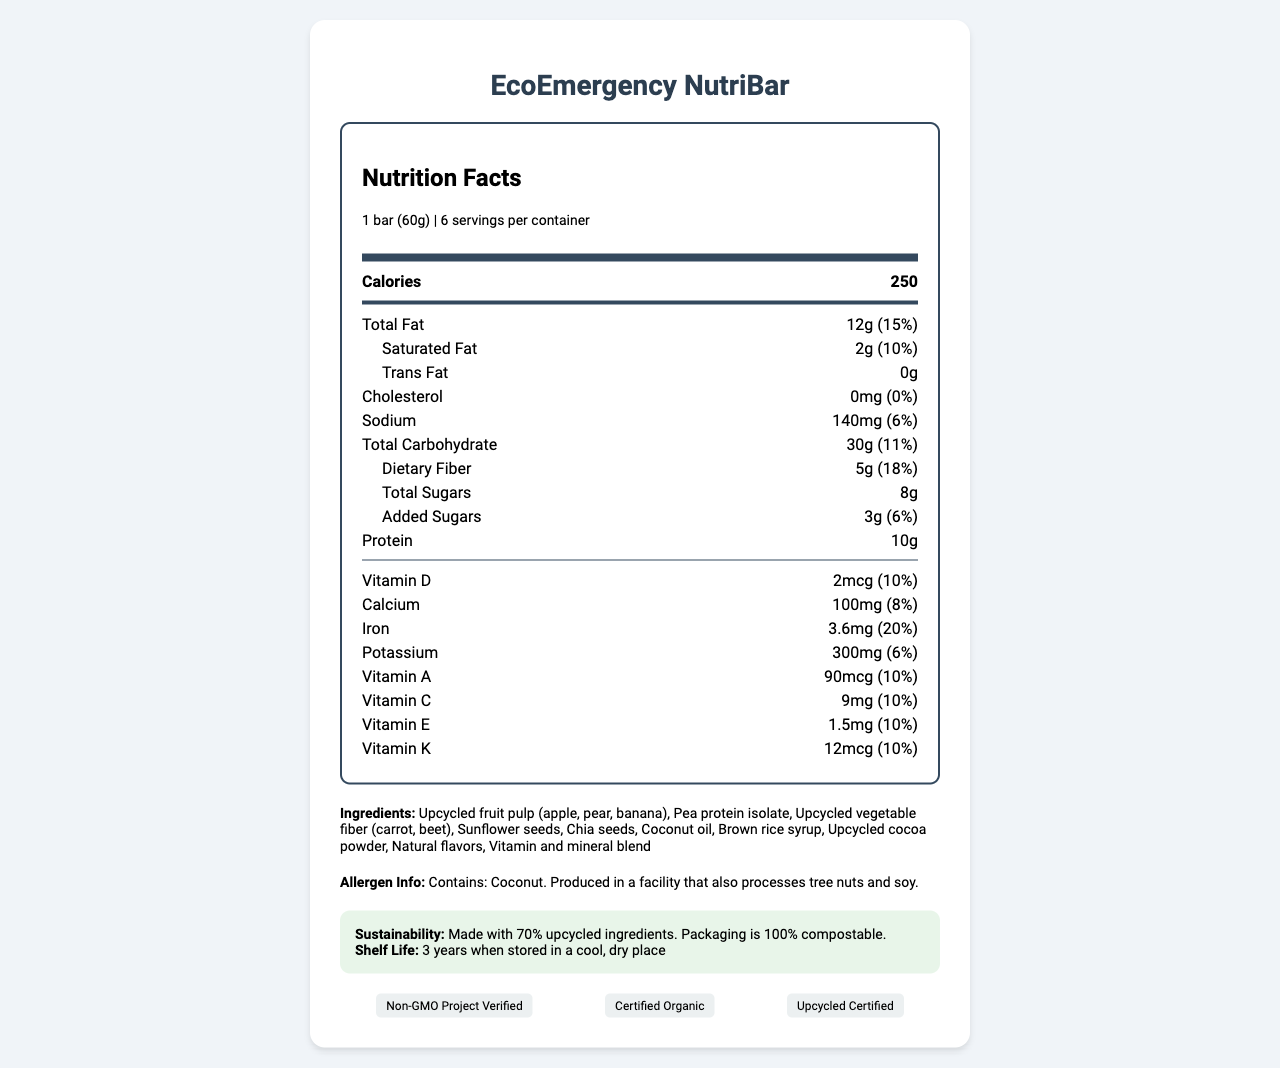what is the serving size of the EcoEmergency NutriBar? The serving size is clearly listed as "1 bar (60g)" in the serving info section at the top of the document.
Answer: 1 bar (60g) How many calories are there per serving? The number of calories per serving is prominently displayed in the bold, central part of the nutrition label.
Answer: 250 How much protein does one bar contain? The amount of protein is listed under the nutrition facts, specifically under the "Protein" section.
Answer: 10g Which ingredient is listed first in the ingredients list? The ingredients are listed in descending order of quantity, and the first ingredient is "Upcycled fruit pulp (apple, pear, banana)".
Answer: Upcycled fruit pulp (apple, pear, banana) What is the daily value percentage of dietary fiber per serving? The daily value percentage for dietary fiber is listed as 18%.
Answer: 18% What is the daily value percentage of vitamin D per serving? The nutrition label lists vitamin D with a daily value percentage of 10%.
Answer: 10% How many servings are in one container? The serving info section at the top of the document states there are 6 servings per container.
Answer: 6 What is the sodium content per serving? The sodium content per serving is listed as 140mg.
Answer: 140mg What certifications does the EcoEmergency NutriBar have? A. Non-GMO Project Verified B. Certified Organic C. Upcycled Certified D. All of the above The certifications section at the bottom lists all three certifications: Non-GMO Project Verified, Certified Organic, and Upcycled Certified.
Answer: D. All of the above Which of these vitamins is NOT listed in the nutrient information? A. Vitamin K B. Vitamin B12 C. Vitamin A The nutrient information lists Vitamin K, Vitamin A, and several others, but Vitamin B12 is not mentioned.
Answer: B. Vitamin B12 Is the EcoEmergency NutriBar made with upcycled ingredients? The sustainability section states that the bar is made with 70% upcycled ingredients.
Answer: Yes Is this product shelf-stable for over 4 years? The shelf life is stated to be 3 years when stored in a cool, dry place, which is below 4 years.
Answer: No Briefly summarize the overall information provided in the EcoEmergency NutriBar document. The document provides detailed nutritional information, ingredient lists, serving sizes, sustainability practices, certifications, and allergen information.
Answer: The EcoEmergency NutriBar is an energy-dense, nutrient-rich emergency ration made from upcycled food waste. Each 60g bar contains 250 calories, 12g of fat, 10g of protein, and various vitamins and minerals. The bar is made with 70% upcycled ingredients and packaged in 100% compostable materials. It has a shelf life of 3 years, is certified Non-GMO, organic, and upcycled, and includes clear allergen information. Where is the EcoEmergency NutriBar produced? The document does not provide information on the production location of the bar.
Answer: Not enough information 